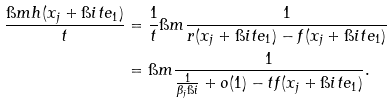<formula> <loc_0><loc_0><loc_500><loc_500>\frac { \i m h ( x _ { j } + \i i t e _ { 1 } ) } { t } & = \frac { 1 } { t } \i m \frac { 1 } { r ( x _ { j } + \i i t e _ { 1 } ) - f ( x _ { j } + \i i t e _ { 1 } ) } \\ & = \i m \frac { 1 } { \frac { 1 } { \beta _ { j } \i i } + o ( 1 ) - t f ( x _ { j } + \i i t e _ { 1 } ) } .</formula> 